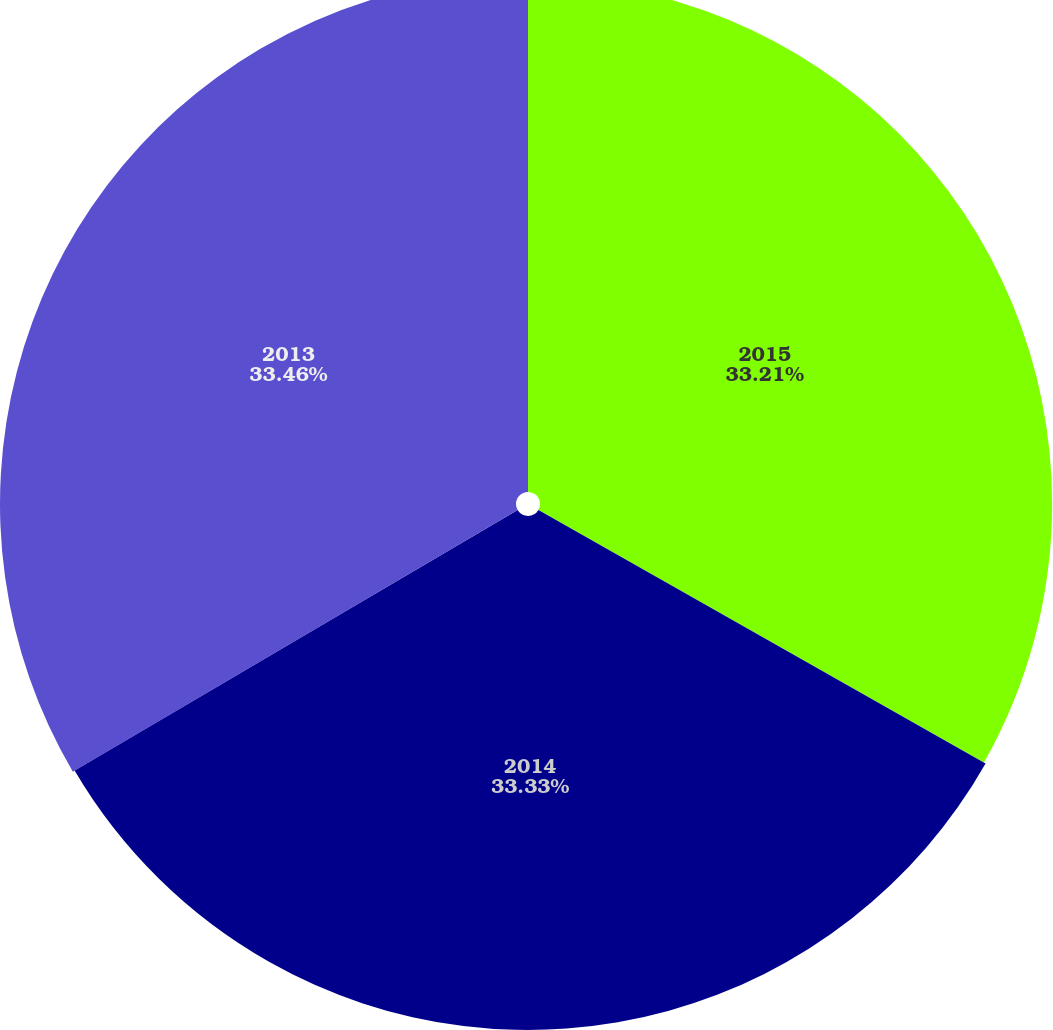Convert chart to OTSL. <chart><loc_0><loc_0><loc_500><loc_500><pie_chart><fcel>2015<fcel>2014<fcel>2013<nl><fcel>33.21%<fcel>33.33%<fcel>33.46%<nl></chart> 